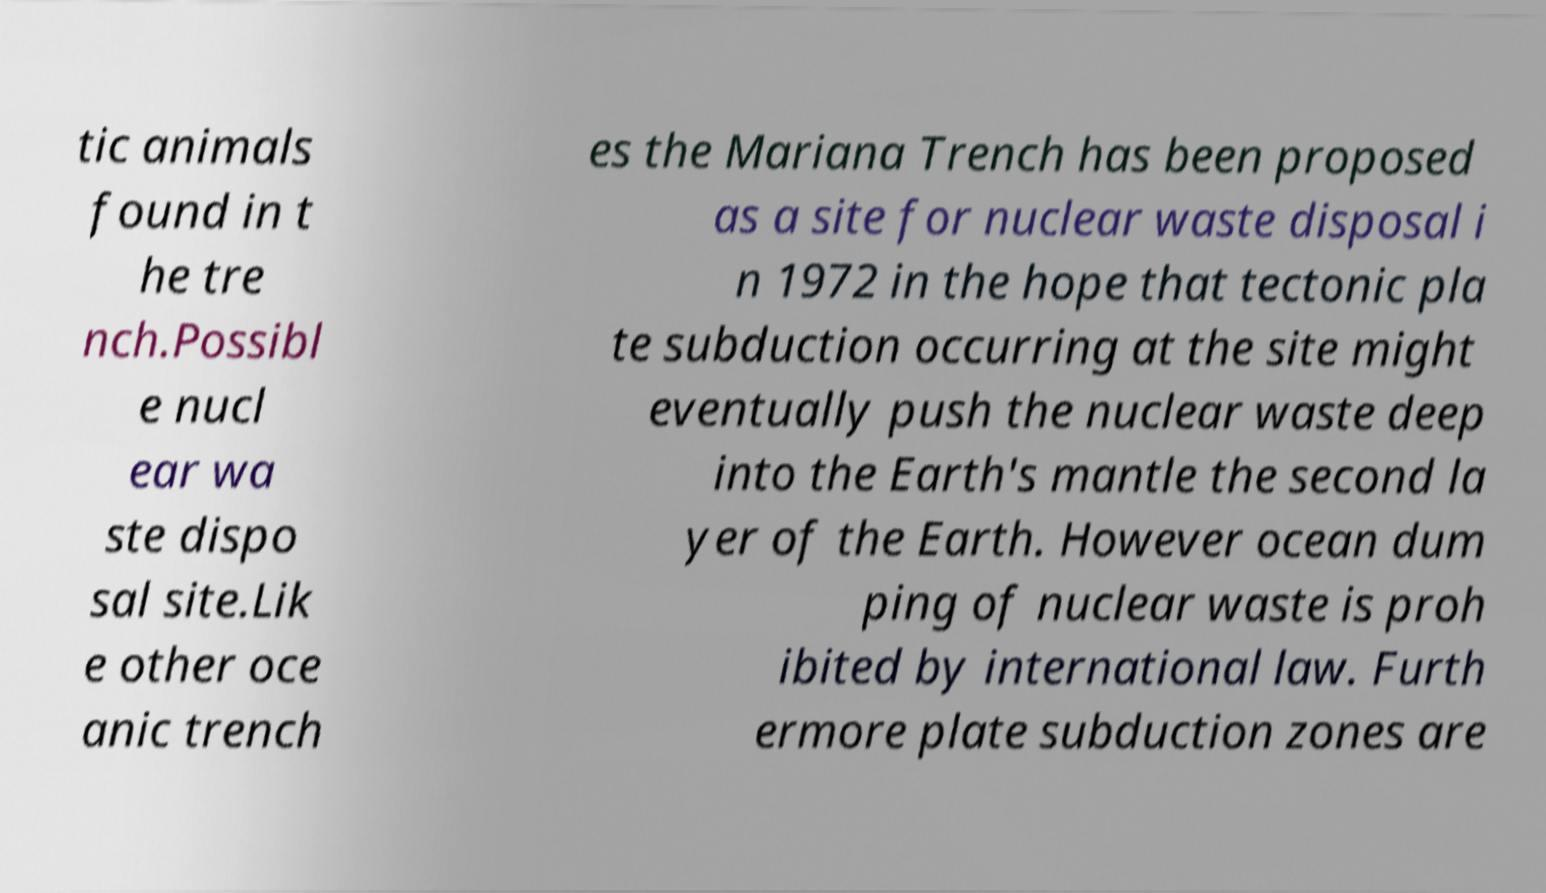For documentation purposes, I need the text within this image transcribed. Could you provide that? tic animals found in t he tre nch.Possibl e nucl ear wa ste dispo sal site.Lik e other oce anic trench es the Mariana Trench has been proposed as a site for nuclear waste disposal i n 1972 in the hope that tectonic pla te subduction occurring at the site might eventually push the nuclear waste deep into the Earth's mantle the second la yer of the Earth. However ocean dum ping of nuclear waste is proh ibited by international law. Furth ermore plate subduction zones are 